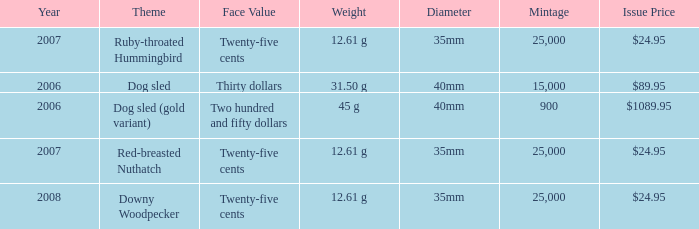I'm looking to parse the entire table for insights. Could you assist me with that? {'header': ['Year', 'Theme', 'Face Value', 'Weight', 'Diameter', 'Mintage', 'Issue Price'], 'rows': [['2007', 'Ruby-throated Hummingbird', 'Twenty-five cents', '12.61 g', '35mm', '25,000', '$24.95'], ['2006', 'Dog sled', 'Thirty dollars', '31.50 g', '40mm', '15,000', '$89.95'], ['2006', 'Dog sled (gold variant)', 'Two hundred and fifty dollars', '45 g', '40mm', '900', '$1089.95'], ['2007', 'Red-breasted Nuthatch', 'Twenty-five cents', '12.61 g', '35mm', '25,000', '$24.95'], ['2008', 'Downy Woodpecker', 'Twenty-five cents', '12.61 g', '35mm', '25,000', '$24.95']]} What is the Diameter of the Dog Sled (gold variant) Theme coin? 40mm. 